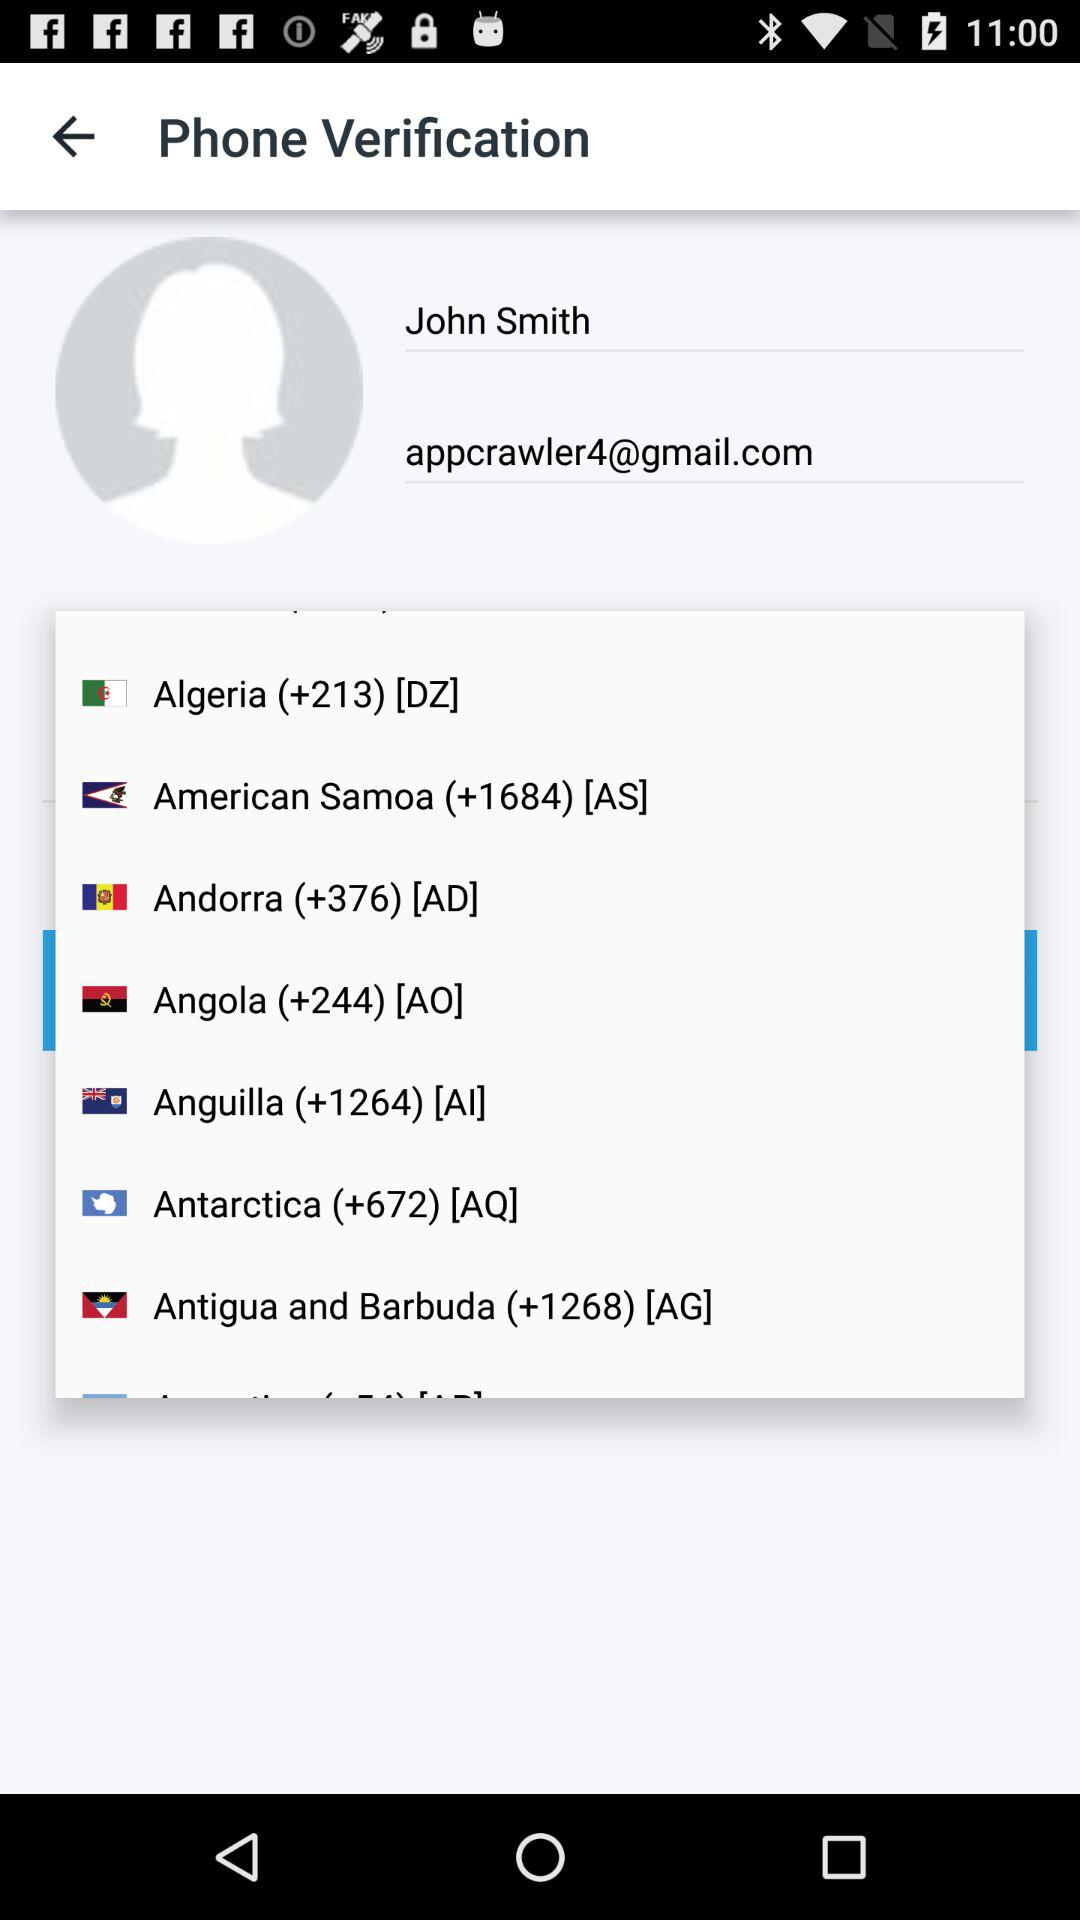What is the email address? The email address is appcrawler4@gmail.com. 